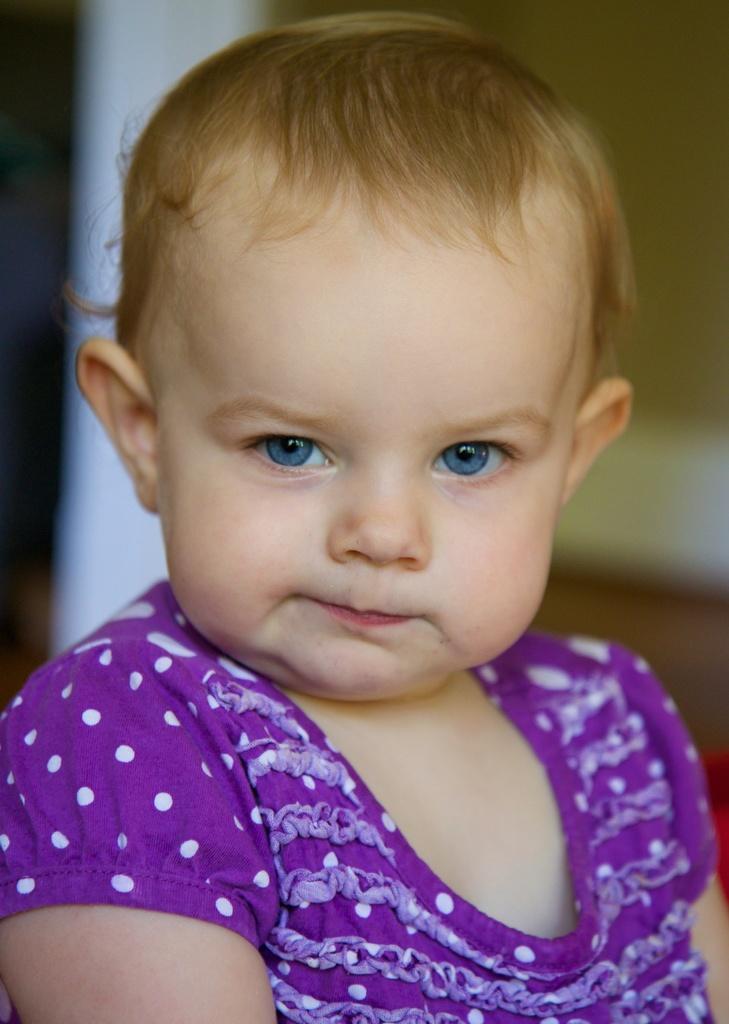How would you summarize this image in a sentence or two? There is a baby in thick pink color dress. And the background is blurred. 